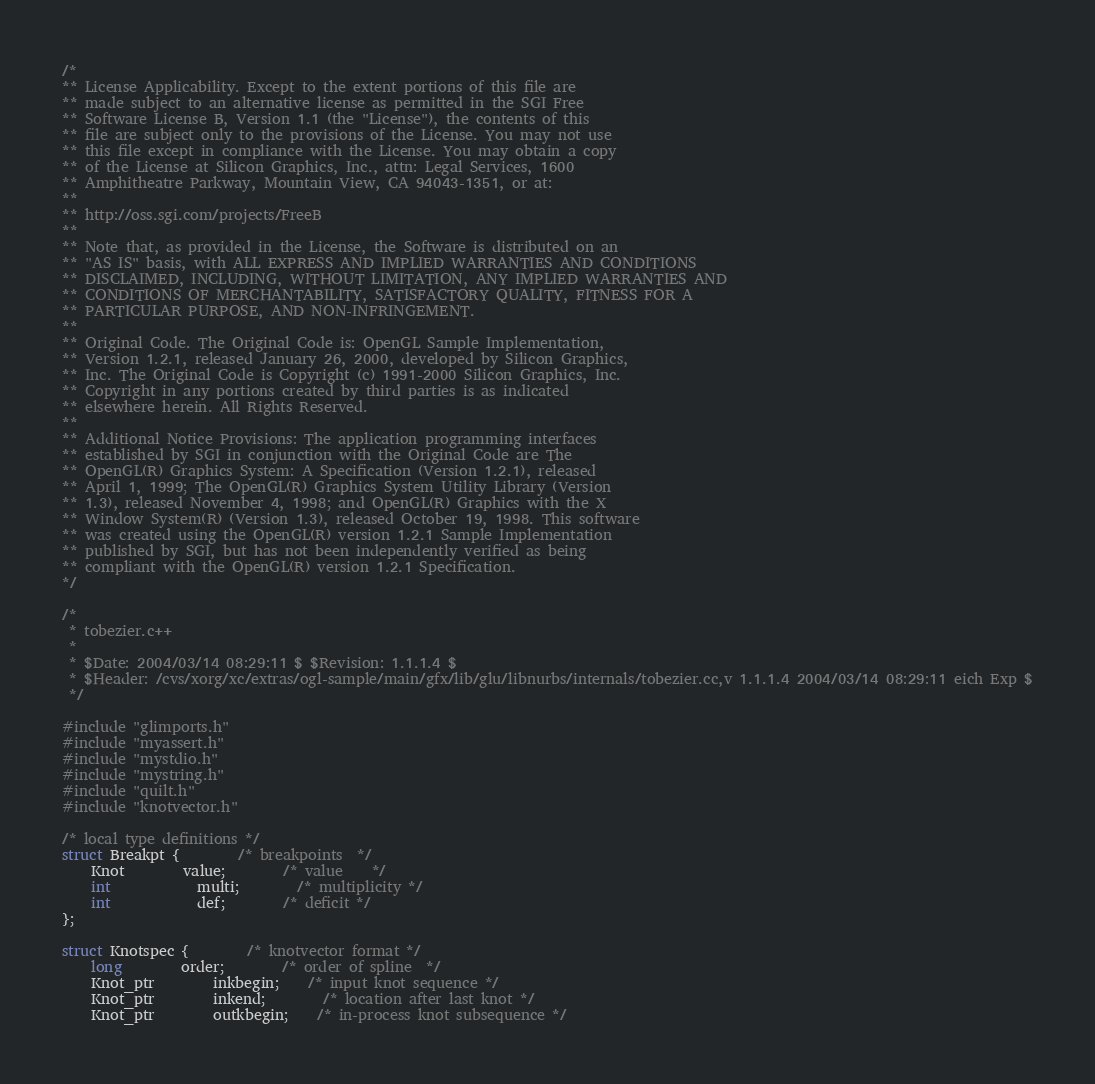Convert code to text. <code><loc_0><loc_0><loc_500><loc_500><_C++_>/*
** License Applicability. Except to the extent portions of this file are
** made subject to an alternative license as permitted in the SGI Free
** Software License B, Version 1.1 (the "License"), the contents of this
** file are subject only to the provisions of the License. You may not use
** this file except in compliance with the License. You may obtain a copy
** of the License at Silicon Graphics, Inc., attn: Legal Services, 1600
** Amphitheatre Parkway, Mountain View, CA 94043-1351, or at:
**
** http://oss.sgi.com/projects/FreeB
**
** Note that, as provided in the License, the Software is distributed on an
** "AS IS" basis, with ALL EXPRESS AND IMPLIED WARRANTIES AND CONDITIONS
** DISCLAIMED, INCLUDING, WITHOUT LIMITATION, ANY IMPLIED WARRANTIES AND
** CONDITIONS OF MERCHANTABILITY, SATISFACTORY QUALITY, FITNESS FOR A
** PARTICULAR PURPOSE, AND NON-INFRINGEMENT.
**
** Original Code. The Original Code is: OpenGL Sample Implementation,
** Version 1.2.1, released January 26, 2000, developed by Silicon Graphics,
** Inc. The Original Code is Copyright (c) 1991-2000 Silicon Graphics, Inc.
** Copyright in any portions created by third parties is as indicated
** elsewhere herein. All Rights Reserved.
**
** Additional Notice Provisions: The application programming interfaces
** established by SGI in conjunction with the Original Code are The
** OpenGL(R) Graphics System: A Specification (Version 1.2.1), released
** April 1, 1999; The OpenGL(R) Graphics System Utility Library (Version
** 1.3), released November 4, 1998; and OpenGL(R) Graphics with the X
** Window System(R) (Version 1.3), released October 19, 1998. This software
** was created using the OpenGL(R) version 1.2.1 Sample Implementation
** published by SGI, but has not been independently verified as being
** compliant with the OpenGL(R) version 1.2.1 Specification.
*/

/* 
 * tobezier.c++
 *
 * $Date: 2004/03/14 08:29:11 $ $Revision: 1.1.1.4 $
 * $Header: /cvs/xorg/xc/extras/ogl-sample/main/gfx/lib/glu/libnurbs/internals/tobezier.cc,v 1.1.1.4 2004/03/14 08:29:11 eich Exp $
 */

#include "glimports.h"
#include "myassert.h"
#include "mystdio.h"
#include "mystring.h"
#include "quilt.h"
#include "knotvector.h"

/* local type definitions */
struct Breakpt {		/* breakpoints	*/
    Knot		value;		/* value	*/
    int			multi;		/* multiplicity	*/
    int			def;		/* deficit */
};

struct Knotspec {		/* knotvector format */
    long		order;		/* order of spline  */
    Knot_ptr		inkbegin;	/* input knot sequence */
    Knot_ptr		inkend;		/* location after last knot */
    Knot_ptr		outkbegin;	/* in-process knot subsequence */</code> 